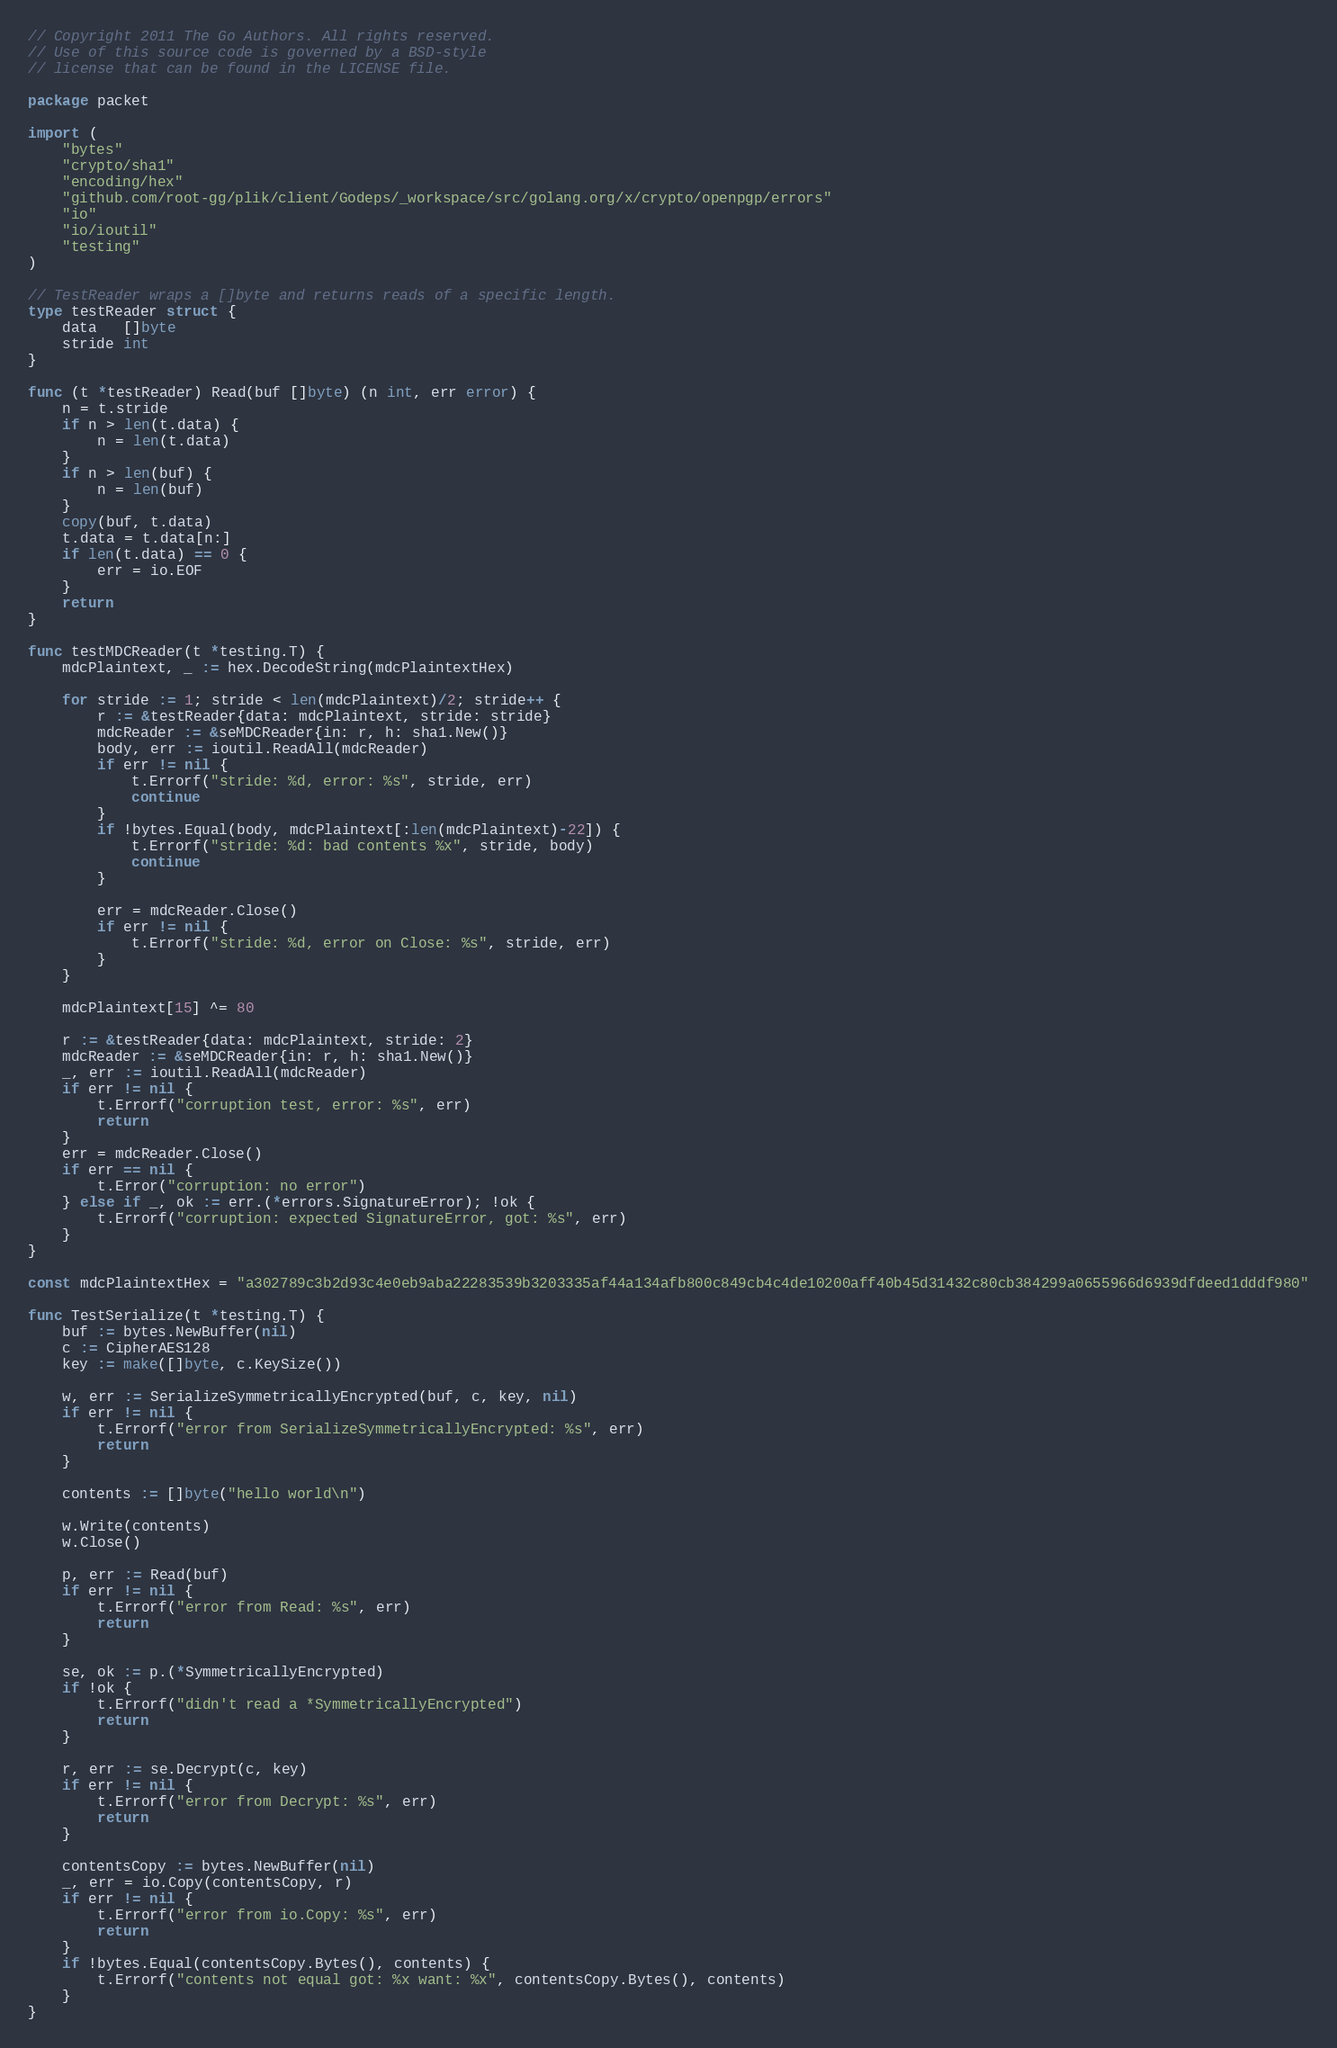<code> <loc_0><loc_0><loc_500><loc_500><_Go_>// Copyright 2011 The Go Authors. All rights reserved.
// Use of this source code is governed by a BSD-style
// license that can be found in the LICENSE file.

package packet

import (
	"bytes"
	"crypto/sha1"
	"encoding/hex"
	"github.com/root-gg/plik/client/Godeps/_workspace/src/golang.org/x/crypto/openpgp/errors"
	"io"
	"io/ioutil"
	"testing"
)

// TestReader wraps a []byte and returns reads of a specific length.
type testReader struct {
	data   []byte
	stride int
}

func (t *testReader) Read(buf []byte) (n int, err error) {
	n = t.stride
	if n > len(t.data) {
		n = len(t.data)
	}
	if n > len(buf) {
		n = len(buf)
	}
	copy(buf, t.data)
	t.data = t.data[n:]
	if len(t.data) == 0 {
		err = io.EOF
	}
	return
}

func testMDCReader(t *testing.T) {
	mdcPlaintext, _ := hex.DecodeString(mdcPlaintextHex)

	for stride := 1; stride < len(mdcPlaintext)/2; stride++ {
		r := &testReader{data: mdcPlaintext, stride: stride}
		mdcReader := &seMDCReader{in: r, h: sha1.New()}
		body, err := ioutil.ReadAll(mdcReader)
		if err != nil {
			t.Errorf("stride: %d, error: %s", stride, err)
			continue
		}
		if !bytes.Equal(body, mdcPlaintext[:len(mdcPlaintext)-22]) {
			t.Errorf("stride: %d: bad contents %x", stride, body)
			continue
		}

		err = mdcReader.Close()
		if err != nil {
			t.Errorf("stride: %d, error on Close: %s", stride, err)
		}
	}

	mdcPlaintext[15] ^= 80

	r := &testReader{data: mdcPlaintext, stride: 2}
	mdcReader := &seMDCReader{in: r, h: sha1.New()}
	_, err := ioutil.ReadAll(mdcReader)
	if err != nil {
		t.Errorf("corruption test, error: %s", err)
		return
	}
	err = mdcReader.Close()
	if err == nil {
		t.Error("corruption: no error")
	} else if _, ok := err.(*errors.SignatureError); !ok {
		t.Errorf("corruption: expected SignatureError, got: %s", err)
	}
}

const mdcPlaintextHex = "a302789c3b2d93c4e0eb9aba22283539b3203335af44a134afb800c849cb4c4de10200aff40b45d31432c80cb384299a0655966d6939dfdeed1dddf980"

func TestSerialize(t *testing.T) {
	buf := bytes.NewBuffer(nil)
	c := CipherAES128
	key := make([]byte, c.KeySize())

	w, err := SerializeSymmetricallyEncrypted(buf, c, key, nil)
	if err != nil {
		t.Errorf("error from SerializeSymmetricallyEncrypted: %s", err)
		return
	}

	contents := []byte("hello world\n")

	w.Write(contents)
	w.Close()

	p, err := Read(buf)
	if err != nil {
		t.Errorf("error from Read: %s", err)
		return
	}

	se, ok := p.(*SymmetricallyEncrypted)
	if !ok {
		t.Errorf("didn't read a *SymmetricallyEncrypted")
		return
	}

	r, err := se.Decrypt(c, key)
	if err != nil {
		t.Errorf("error from Decrypt: %s", err)
		return
	}

	contentsCopy := bytes.NewBuffer(nil)
	_, err = io.Copy(contentsCopy, r)
	if err != nil {
		t.Errorf("error from io.Copy: %s", err)
		return
	}
	if !bytes.Equal(contentsCopy.Bytes(), contents) {
		t.Errorf("contents not equal got: %x want: %x", contentsCopy.Bytes(), contents)
	}
}
</code> 